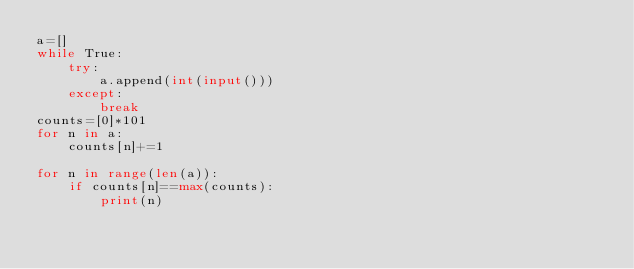<code> <loc_0><loc_0><loc_500><loc_500><_Python_>a=[]
while True:
    try:
        a.append(int(input()))
    except:
        break
counts=[0]*101
for n in a:
    counts[n]+=1
    
for n in range(len(a)):
    if counts[n]==max(counts):
        print(n)
</code> 